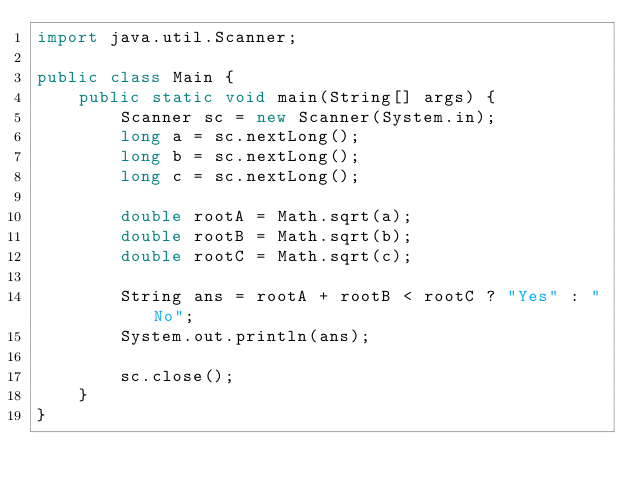<code> <loc_0><loc_0><loc_500><loc_500><_Java_>import java.util.Scanner;

public class Main {
	public static void main(String[] args) {
		Scanner sc = new Scanner(System.in);
		long a = sc.nextLong();
		long b = sc.nextLong();
		long c = sc.nextLong();
		
		double rootA = Math.sqrt(a);
		double rootB = Math.sqrt(b);
		double rootC = Math.sqrt(c);
		
		String ans = rootA + rootB < rootC ? "Yes" : "No";
		System.out.println(ans);
		
		sc.close();
	}
}
</code> 